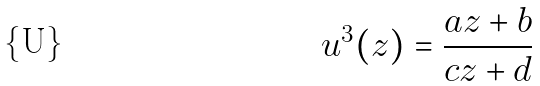<formula> <loc_0><loc_0><loc_500><loc_500>u ^ { 3 } ( z ) = \frac { a z + b } { c z + d }</formula> 